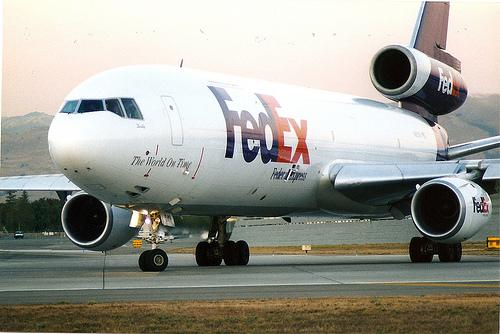Question: who owns the plane?
Choices:
A. FedEx.
B. Delta.
C. Donald Trump.
D. Boeing.
Answer with the letter. Answer: A Question: who flies planes?
Choices:
A. Crop Dusters.
B. Military Personnel.
C. Pilot.
D. Airlines.
Answer with the letter. Answer: C Question: what is the subject of the photo?
Choices:
A. Baseball game.
B. Plane.
C. Motorcycle.
D. Statue.
Answer with the letter. Answer: B Question: where is the plane currently?
Choices:
A. Sky.
B. Terminal.
C. Hanger.
D. Runway.
Answer with the letter. Answer: D Question: what color is runway?
Choices:
A. Brown.
B. Black.
C. White.
D. Gray.
Answer with the letter. Answer: D Question: how many engines does this plane have?
Choices:
A. Two.
B. One.
C. Three.
D. Four.
Answer with the letter. Answer: C 